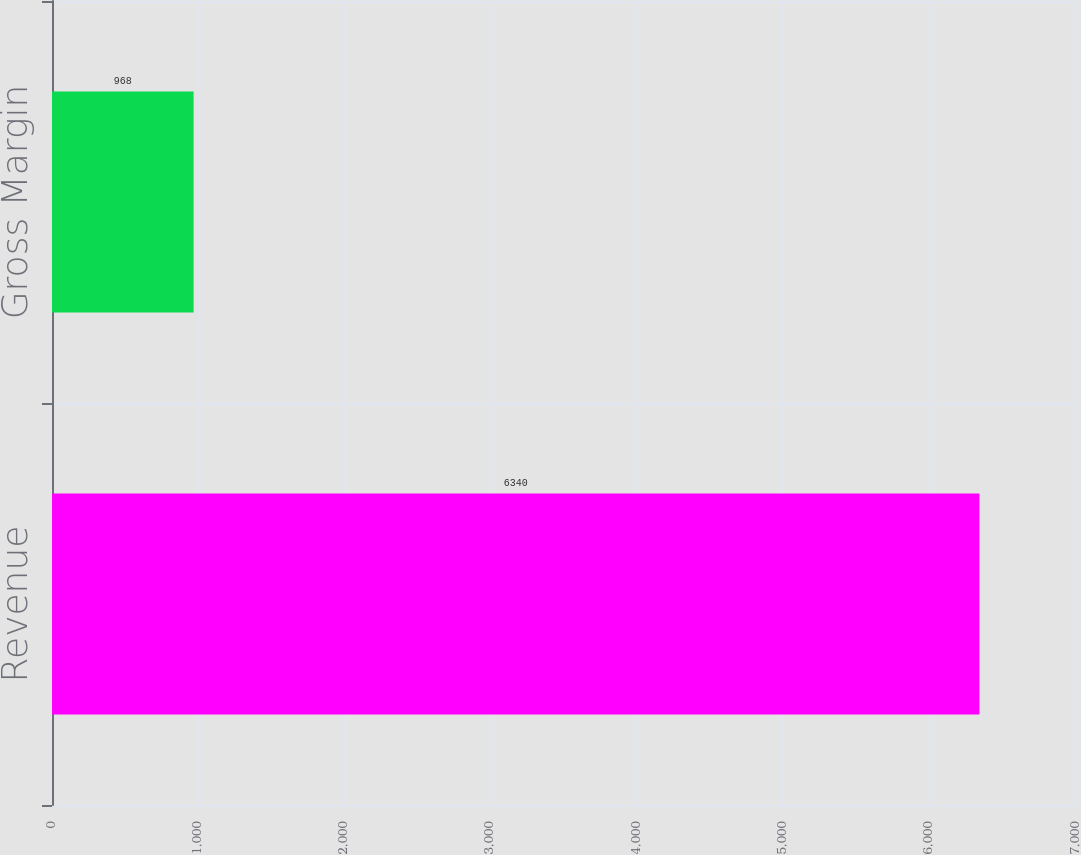Convert chart. <chart><loc_0><loc_0><loc_500><loc_500><bar_chart><fcel>Revenue<fcel>Gross Margin<nl><fcel>6340<fcel>968<nl></chart> 